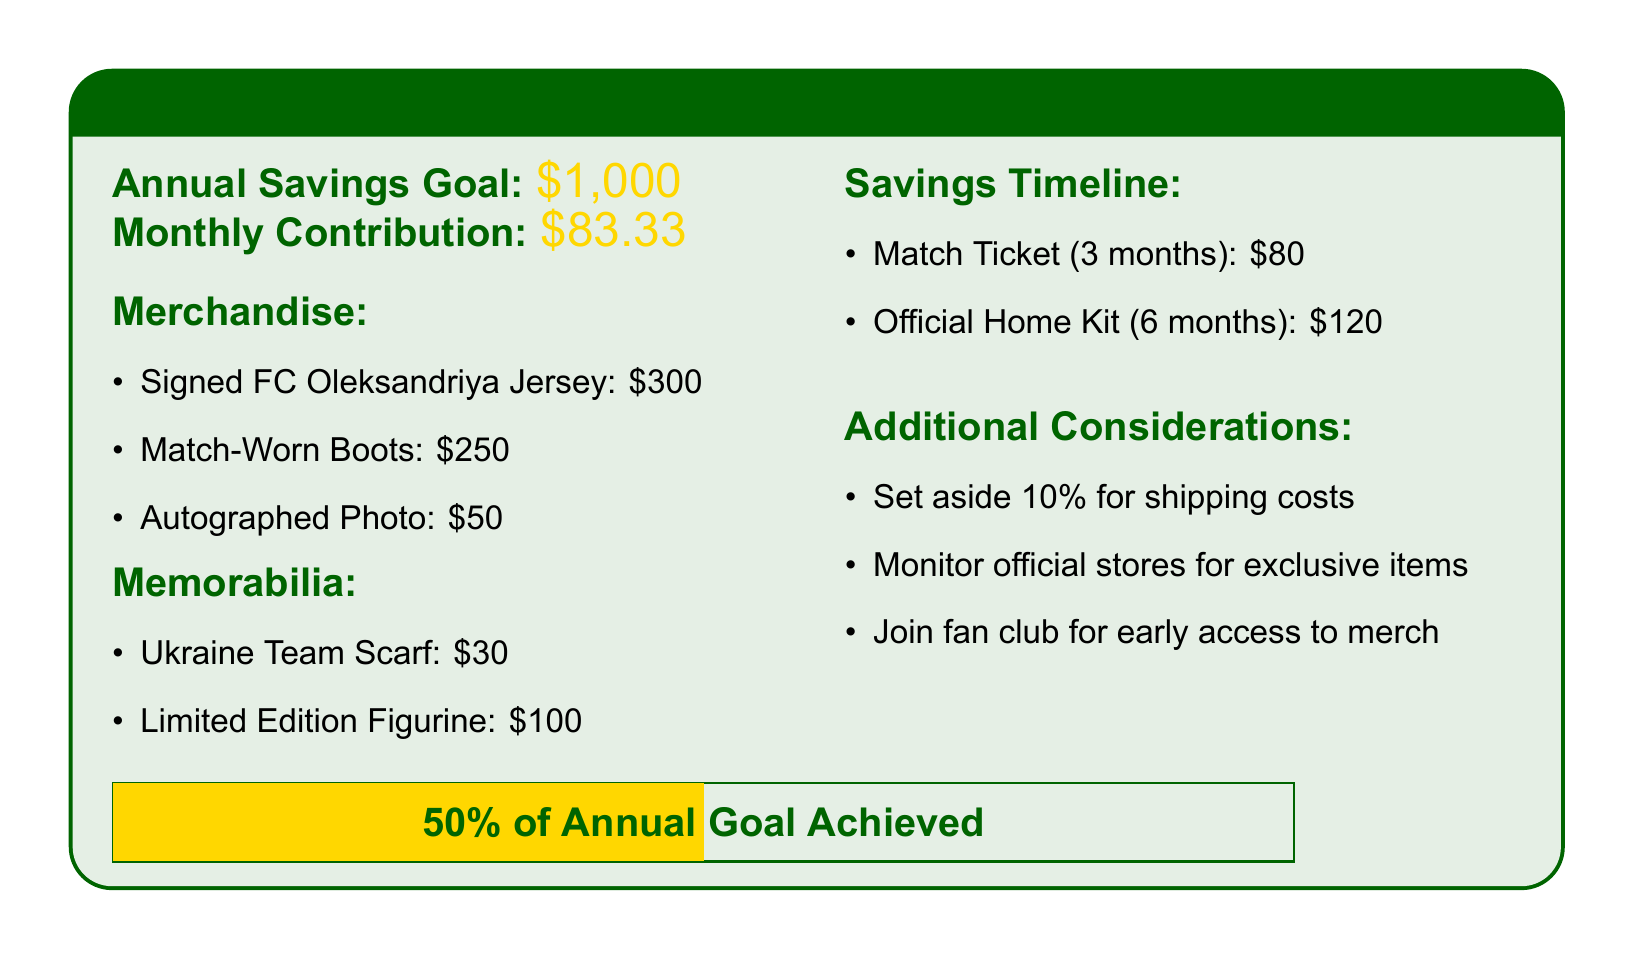What is the annual savings goal? The annual savings goal is clearly stated in the document as one thousand dollars.
Answer: $1,000 How much should be contributed monthly? The monthly contribution is specified in the document as eighty-three dollars and thirty-three cents.
Answer: $83.33 What is the cost of the signed FC Oleksandriya jersey? The document lists the price of the signed FC Oleksandriya jersey, which is three hundred dollars.
Answer: $300 What percentage of the annual goal is achieved? The document indicates that fifty percent of the annual goal has been achieved, as shown in the visual depiction.
Answer: 50% What is one of the additional considerations mentioned? The document states there are multiple considerations, one being to set aside ten percent for shipping costs.
Answer: Set aside 10% for shipping costs How much does the limited edition figurine cost? The document mentions the cost of the limited edition figurine, which is one hundred dollars.
Answer: $100 For how many months is the match ticket budgeted? The document specifies that the match ticket is budgeted for three months.
Answer: 3 months What is the total estimated cost for the official home kit? The document states the estimated cost for the official home kit is one hundred twenty dollars.
Answer: $120 